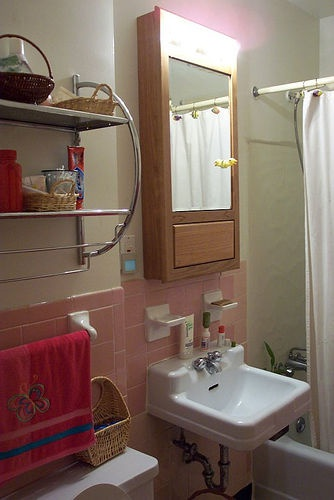Describe the objects in this image and their specific colors. I can see sink in gray, darkgray, lightgray, and maroon tones, toilet in gray, darkgray, maroon, and black tones, and bottle in gray, maroon, and brown tones in this image. 